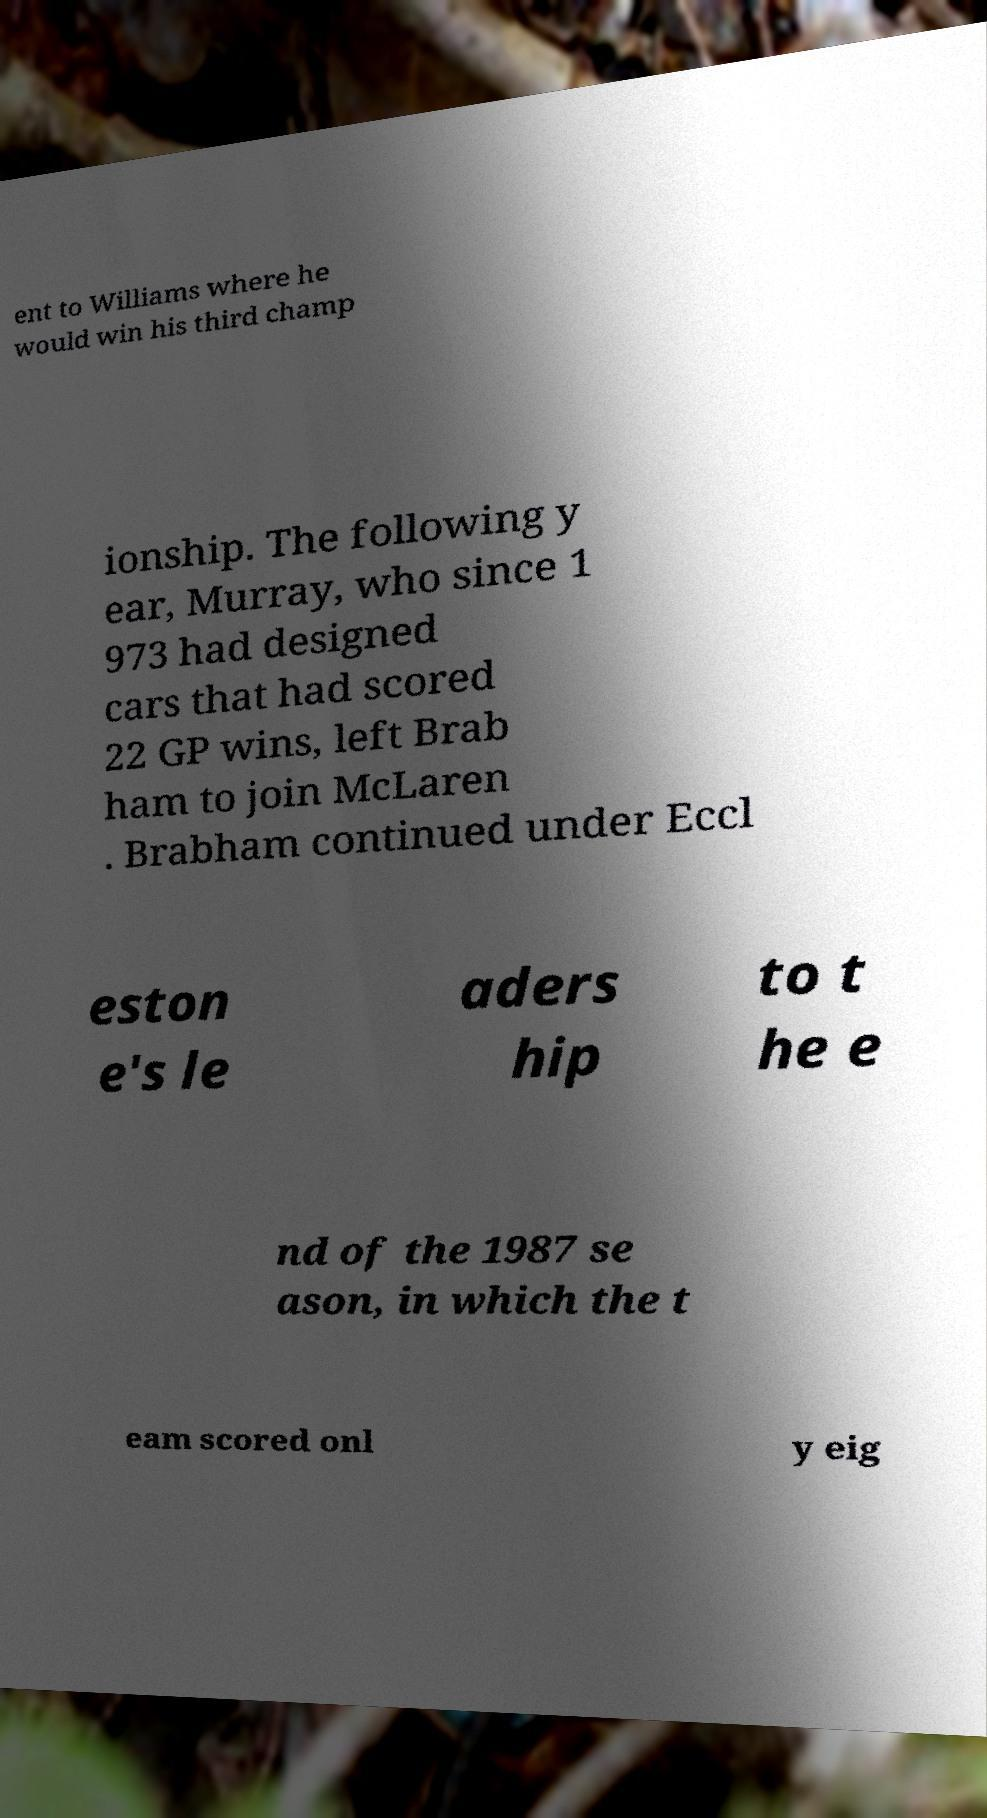Can you accurately transcribe the text from the provided image for me? ent to Williams where he would win his third champ ionship. The following y ear, Murray, who since 1 973 had designed cars that had scored 22 GP wins, left Brab ham to join McLaren . Brabham continued under Eccl eston e's le aders hip to t he e nd of the 1987 se ason, in which the t eam scored onl y eig 